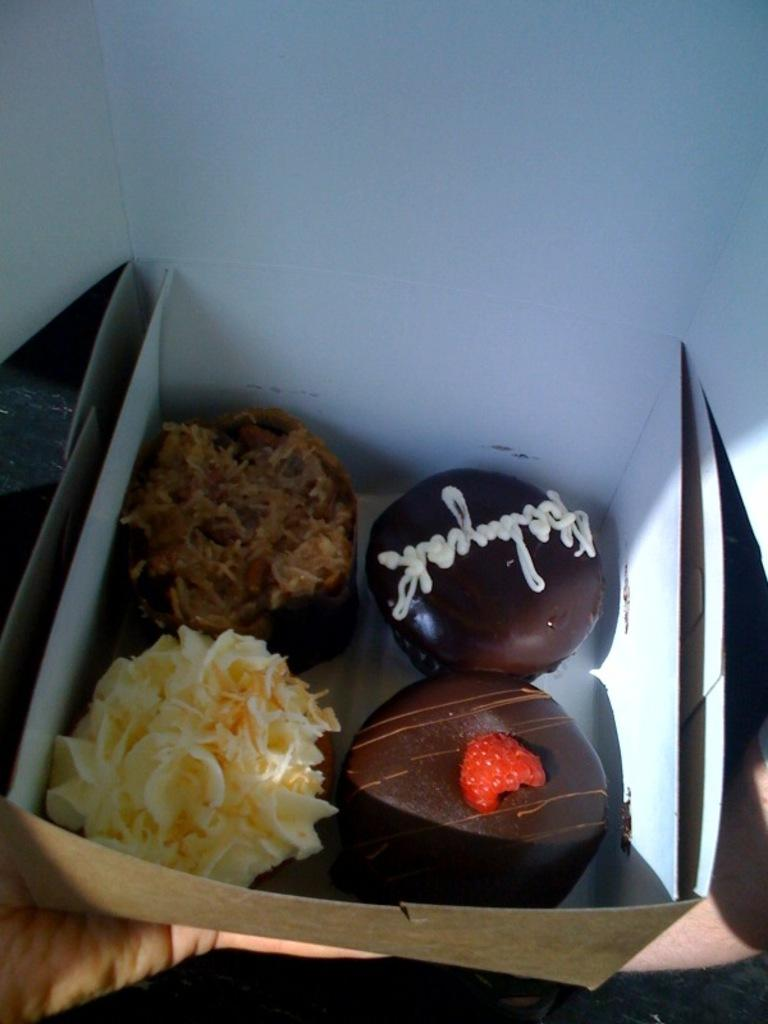What object is present in the image? There is a box in the image. What is inside the box? There is food inside the box. Can you see a picture of someone's feet inside the box? There is no picture of feet inside the box; it contains food. Is there a cap visible inside the box? There is no cap visible inside the box; it contains food. 